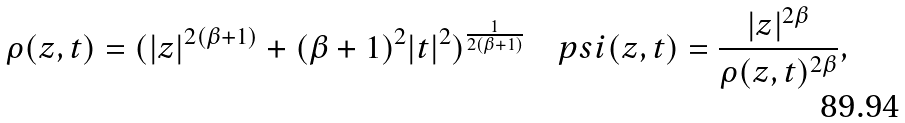<formula> <loc_0><loc_0><loc_500><loc_500>\rho ( z , t ) = ( | z | ^ { 2 ( \beta + 1 ) } + ( \beta + 1 ) ^ { 2 } | t | ^ { 2 } ) ^ { \frac { 1 } { 2 ( \beta + 1 ) } } \quad p s i ( z , t ) = \frac { | z | ^ { 2 \beta } } { \rho ( z , t ) ^ { 2 \beta } } ,</formula> 